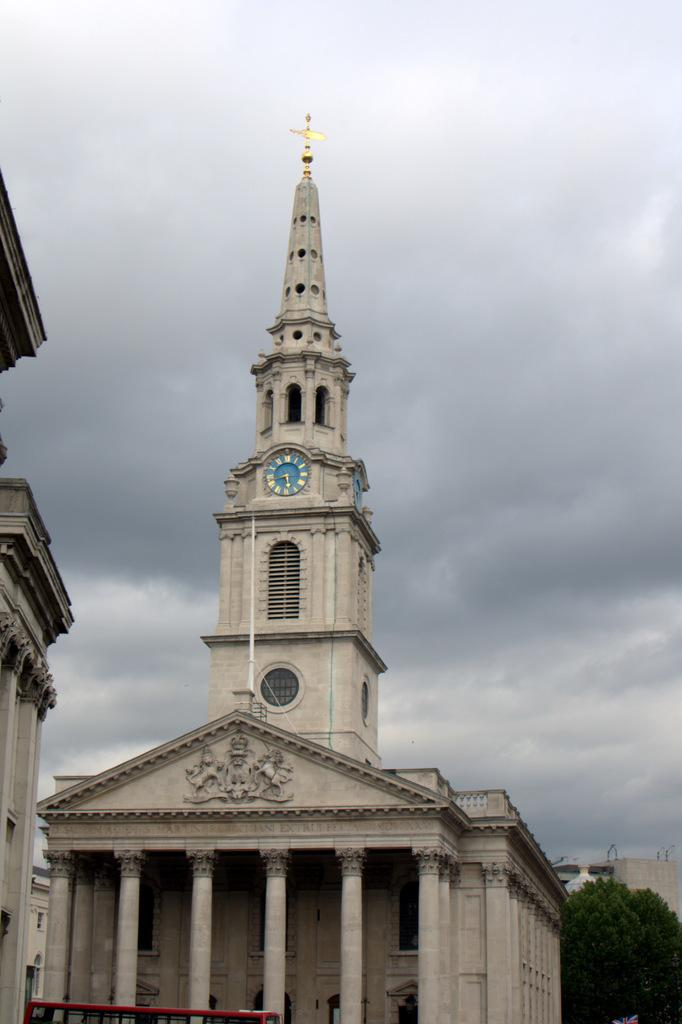What is the main structure in the image? There is a clock tower in the image. What other buildings are present in the image? There is a house in the image. What architectural features can be seen in the image? There are pillars and walls visible in the image. What type of vegetation is present at the bottom of the image? Trees are visible at the bottom of the image. What color is visible at the bottom of the image? There is a red color visible at the bottom of the image. What is the weather like in the image? The sky is cloudy in the background of the image. What type of credit card is being used to purchase the dress in the image? There is no credit card or dress present in the image; it features a clock tower, a house, pillars, walls, trees, and a cloudy sky. 